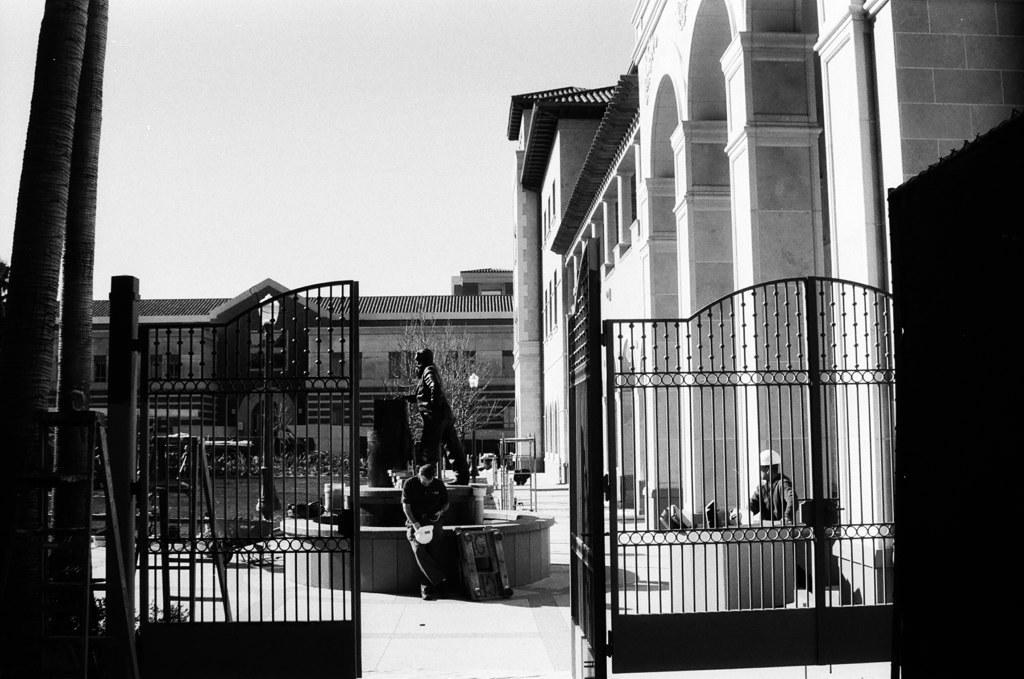In one or two sentences, can you explain what this image depicts? This is a black and white image which is clicked outside. In the foreground we can see the metal gate and in the center there is a sculpture of a person and we can see the two persons sitting and there are some items placed on the ground and we can see the buildings. In the background there is a sky. 